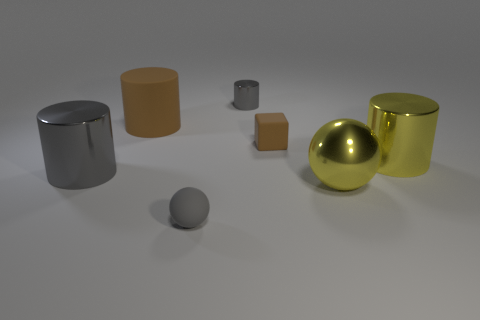Subtract 2 cylinders. How many cylinders are left? 2 Subtract all yellow cylinders. How many cylinders are left? 3 Subtract all cyan cylinders. Subtract all gray spheres. How many cylinders are left? 4 Add 2 big yellow shiny spheres. How many objects exist? 9 Subtract all cylinders. How many objects are left? 3 Add 2 brown matte things. How many brown matte things are left? 4 Add 5 large cyan metal things. How many large cyan metal things exist? 5 Subtract 0 brown spheres. How many objects are left? 7 Subtract all tiny red matte objects. Subtract all small gray cylinders. How many objects are left? 6 